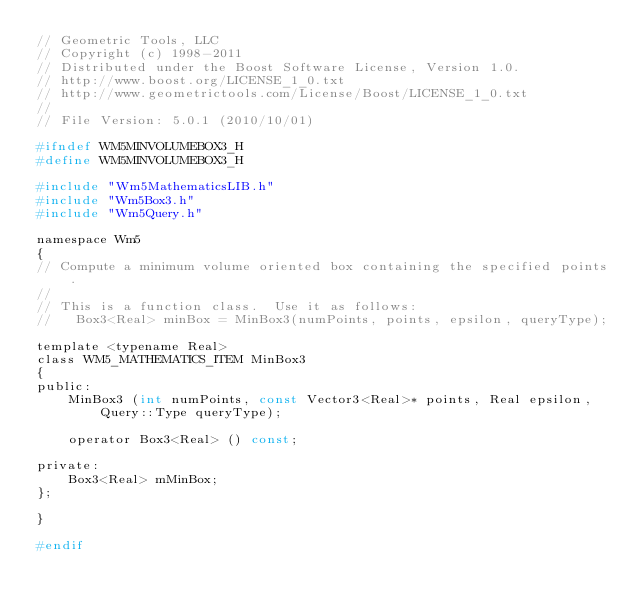<code> <loc_0><loc_0><loc_500><loc_500><_C_>// Geometric Tools, LLC
// Copyright (c) 1998-2011
// Distributed under the Boost Software License, Version 1.0.
// http://www.boost.org/LICENSE_1_0.txt
// http://www.geometrictools.com/License/Boost/LICENSE_1_0.txt
//
// File Version: 5.0.1 (2010/10/01)

#ifndef WM5MINVOLUMEBOX3_H
#define WM5MINVOLUMEBOX3_H

#include "Wm5MathematicsLIB.h"
#include "Wm5Box3.h"
#include "Wm5Query.h"

namespace Wm5
{
// Compute a minimum volume oriented box containing the specified points.
//
// This is a function class.  Use it as follows:
//   Box3<Real> minBox = MinBox3(numPoints, points, epsilon, queryType);

template <typename Real>
class WM5_MATHEMATICS_ITEM MinBox3
{
public:
    MinBox3 (int numPoints, const Vector3<Real>* points, Real epsilon,
        Query::Type queryType);

    operator Box3<Real> () const;

private:
    Box3<Real> mMinBox;
};

}

#endif
</code> 